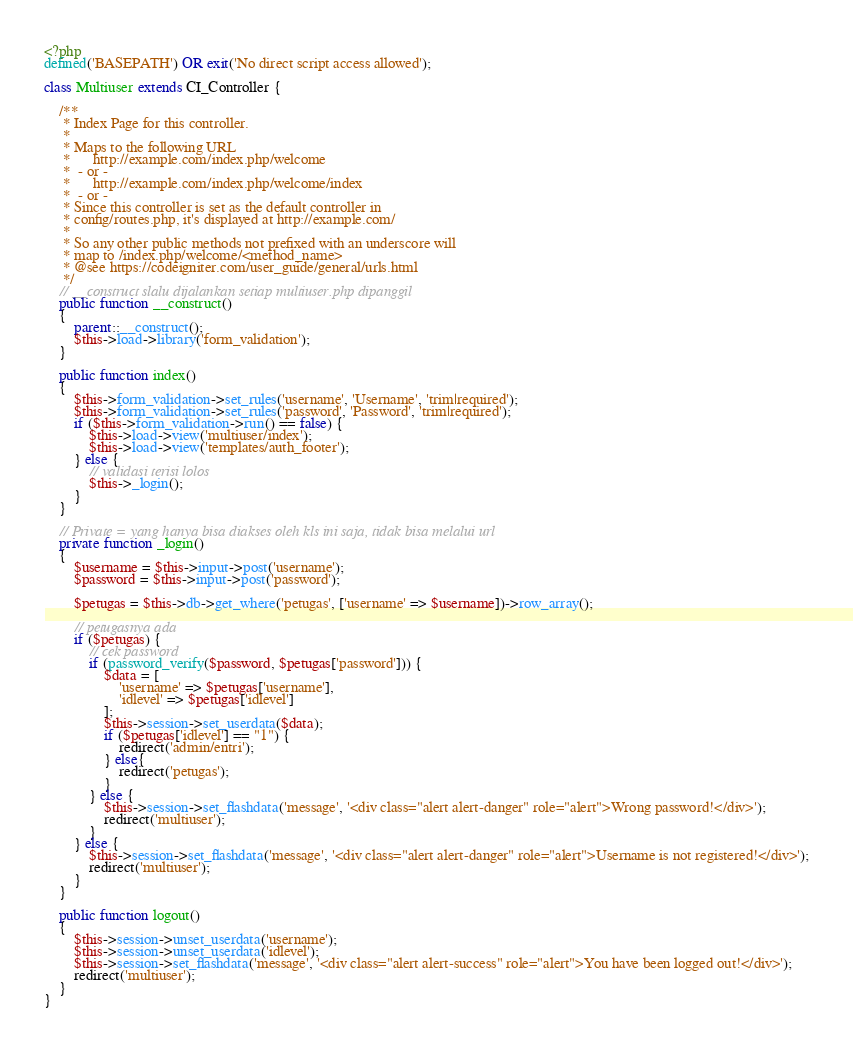<code> <loc_0><loc_0><loc_500><loc_500><_PHP_><?php
defined('BASEPATH') OR exit('No direct script access allowed');

class Multiuser extends CI_Controller {

	/**
	 * Index Page for this controller.
	 *
	 * Maps to the following URL
	 * 		http://example.com/index.php/welcome
	 *	- or -
	 * 		http://example.com/index.php/welcome/index
	 *	- or -
	 * Since this controller is set as the default controller in
	 * config/routes.php, it's displayed at http://example.com/
	 *
	 * So any other public methods not prefixed with an underscore will
	 * map to /index.php/welcome/<method_name>
	 * @see https://codeigniter.com/user_guide/general/urls.html
	 */
	// __construct slalu dijalankan setiap multiuser.php dipanggil
	public function __construct()
	{
		parent::__construct();
		$this->load->library('form_validation');
	}

	public function index()
	{
		$this->form_validation->set_rules('username', 'Username', 'trim|required');
		$this->form_validation->set_rules('password', 'Password', 'trim|required');
		if ($this->form_validation->run() == false) {
			$this->load->view('multiuser/index');
			$this->load->view('templates/auth_footer');	
		} else {
			// validasi terisi lolos
			$this->_login();
		}
	}

	// Private = yang hanya bisa diakses oleh kls ini saja, tidak bisa melalui url
	private function _login()
	{
		$username = $this->input->post('username');
		$password = $this->input->post('password');

		$petugas = $this->db->get_where('petugas', ['username' => $username])->row_array();

		// petugasnya ada
		if ($petugas) {
			// cek password
			if (password_verify($password, $petugas['password'])) {
				$data = [
					'username' => $petugas['username'],
					'idlevel' => $petugas['idlevel']
				];
				$this->session->set_userdata($data);
				if ($petugas['idlevel'] == "1") {
					redirect('admin/entri');	
				} else{
					redirect('petugas');
				}
			} else {
				$this->session->set_flashdata('message', '<div class="alert alert-danger" role="alert">Wrong password!</div>');
				redirect('multiuser');
			}
		} else {
			$this->session->set_flashdata('message', '<div class="alert alert-danger" role="alert">Username is not registered!</div>');
			redirect('multiuser');
		}
	}

	public function logout()
	{
		$this->session->unset_userdata('username');
		$this->session->unset_userdata('idlevel');
		$this->session->set_flashdata('message', '<div class="alert alert-success" role="alert">You have been logged out!</div>');
		redirect('multiuser');
	}
}</code> 